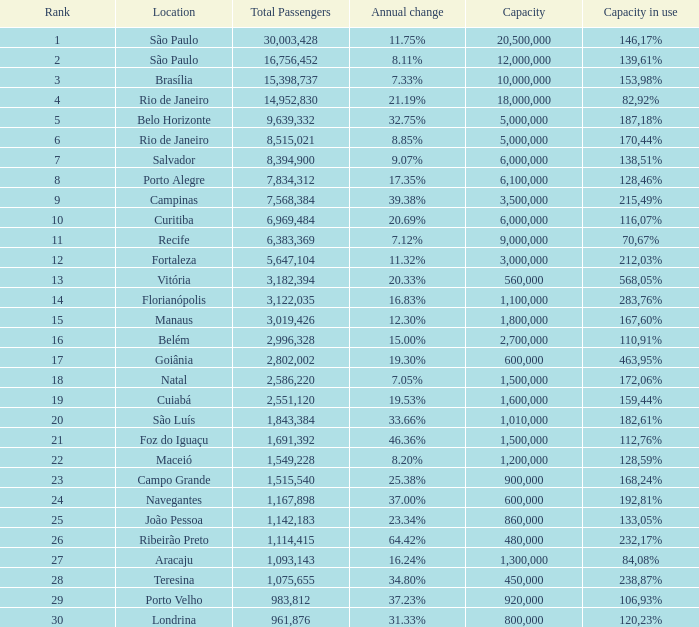What location has an in use capacity of 167,60%? 1800000.0. Parse the full table. {'header': ['Rank', 'Location', 'Total Passengers', 'Annual change', 'Capacity', 'Capacity in use'], 'rows': [['1', 'São Paulo', '30,003,428', '11.75%', '20,500,000', '146,17%'], ['2', 'São Paulo', '16,756,452', '8.11%', '12,000,000', '139,61%'], ['3', 'Brasília', '15,398,737', '7.33%', '10,000,000', '153,98%'], ['4', 'Rio de Janeiro', '14,952,830', '21.19%', '18,000,000', '82,92%'], ['5', 'Belo Horizonte', '9,639,332', '32.75%', '5,000,000', '187,18%'], ['6', 'Rio de Janeiro', '8,515,021', '8.85%', '5,000,000', '170,44%'], ['7', 'Salvador', '8,394,900', '9.07%', '6,000,000', '138,51%'], ['8', 'Porto Alegre', '7,834,312', '17.35%', '6,100,000', '128,46%'], ['9', 'Campinas', '7,568,384', '39.38%', '3,500,000', '215,49%'], ['10', 'Curitiba', '6,969,484', '20.69%', '6,000,000', '116,07%'], ['11', 'Recife', '6,383,369', '7.12%', '9,000,000', '70,67%'], ['12', 'Fortaleza', '5,647,104', '11.32%', '3,000,000', '212,03%'], ['13', 'Vitória', '3,182,394', '20.33%', '560,000', '568,05%'], ['14', 'Florianópolis', '3,122,035', '16.83%', '1,100,000', '283,76%'], ['15', 'Manaus', '3,019,426', '12.30%', '1,800,000', '167,60%'], ['16', 'Belém', '2,996,328', '15.00%', '2,700,000', '110,91%'], ['17', 'Goiânia', '2,802,002', '19.30%', '600,000', '463,95%'], ['18', 'Natal', '2,586,220', '7.05%', '1,500,000', '172,06%'], ['19', 'Cuiabá', '2,551,120', '19.53%', '1,600,000', '159,44%'], ['20', 'São Luís', '1,843,384', '33.66%', '1,010,000', '182,61%'], ['21', 'Foz do Iguaçu', '1,691,392', '46.36%', '1,500,000', '112,76%'], ['22', 'Maceió', '1,549,228', '8.20%', '1,200,000', '128,59%'], ['23', 'Campo Grande', '1,515,540', '25.38%', '900,000', '168,24%'], ['24', 'Navegantes', '1,167,898', '37.00%', '600,000', '192,81%'], ['25', 'João Pessoa', '1,142,183', '23.34%', '860,000', '133,05%'], ['26', 'Ribeirão Preto', '1,114,415', '64.42%', '480,000', '232,17%'], ['27', 'Aracaju', '1,093,143', '16.24%', '1,300,000', '84,08%'], ['28', 'Teresina', '1,075,655', '34.80%', '450,000', '238,87%'], ['29', 'Porto Velho', '983,812', '37.23%', '920,000', '106,93%'], ['30', 'Londrina', '961,876', '31.33%', '800,000', '120,23%']]} 